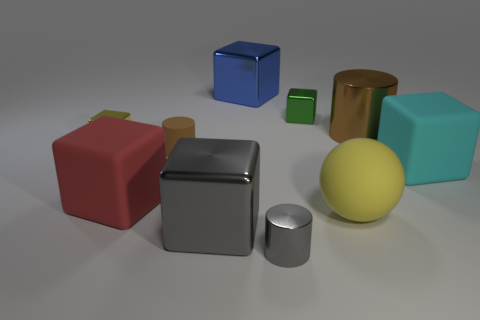Subtract all brown cylinders. How many cylinders are left? 1 Subtract all shiny cubes. How many cubes are left? 2 Subtract all cubes. How many objects are left? 4 Subtract all blue cylinders. Subtract all yellow spheres. How many cylinders are left? 3 Subtract all yellow spheres. How many cyan cylinders are left? 0 Subtract all tiny cyan cylinders. Subtract all small gray metallic objects. How many objects are left? 9 Add 1 small gray cylinders. How many small gray cylinders are left? 2 Add 6 small blue metal cylinders. How many small blue metal cylinders exist? 6 Subtract 1 green blocks. How many objects are left? 9 Subtract 4 cubes. How many cubes are left? 2 